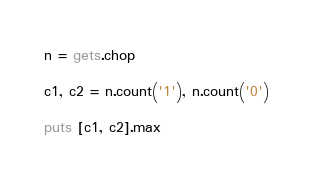<code> <loc_0><loc_0><loc_500><loc_500><_Ruby_>n = gets.chop

c1, c2 = n.count('1'), n.count('0')

puts [c1, c2].max
</code> 